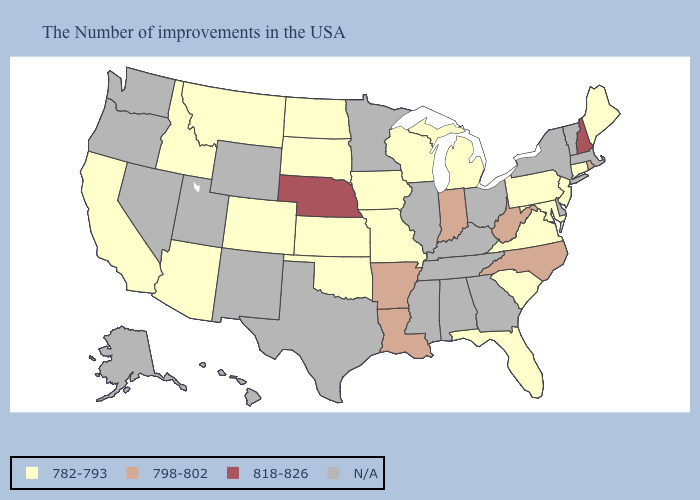Among the states that border Massachusetts , does Rhode Island have the lowest value?
Short answer required. No. Does the map have missing data?
Quick response, please. Yes. Which states have the highest value in the USA?
Quick response, please. New Hampshire, Nebraska. What is the value of Nebraska?
Quick response, please. 818-826. Name the states that have a value in the range 818-826?
Be succinct. New Hampshire, Nebraska. Name the states that have a value in the range 818-826?
Answer briefly. New Hampshire, Nebraska. What is the highest value in states that border Louisiana?
Be succinct. 798-802. How many symbols are there in the legend?
Answer briefly. 4. Among the states that border Colorado , does Arizona have the lowest value?
Short answer required. Yes. What is the value of Oregon?
Write a very short answer. N/A. What is the value of New York?
Be succinct. N/A. Name the states that have a value in the range 798-802?
Keep it brief. Rhode Island, North Carolina, West Virginia, Indiana, Louisiana, Arkansas. What is the value of South Dakota?
Be succinct. 782-793. 